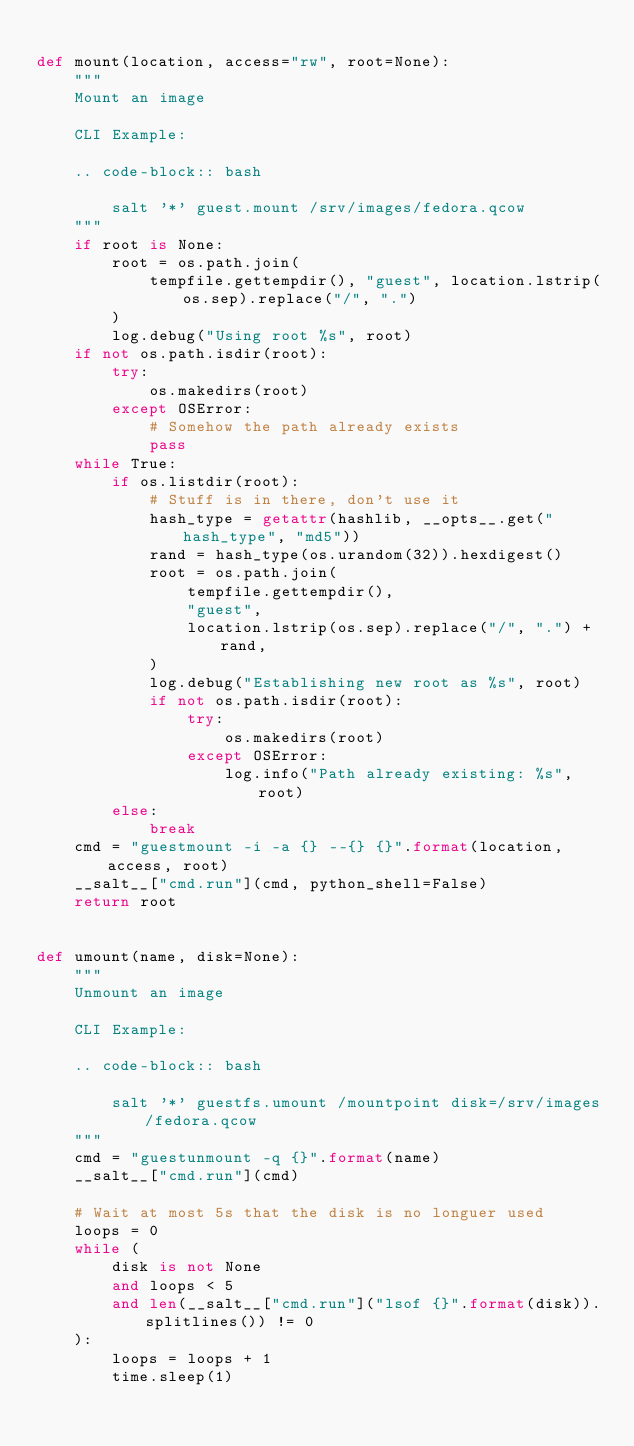<code> <loc_0><loc_0><loc_500><loc_500><_Python_>
def mount(location, access="rw", root=None):
    """
    Mount an image

    CLI Example:

    .. code-block:: bash

        salt '*' guest.mount /srv/images/fedora.qcow
    """
    if root is None:
        root = os.path.join(
            tempfile.gettempdir(), "guest", location.lstrip(os.sep).replace("/", ".")
        )
        log.debug("Using root %s", root)
    if not os.path.isdir(root):
        try:
            os.makedirs(root)
        except OSError:
            # Somehow the path already exists
            pass
    while True:
        if os.listdir(root):
            # Stuff is in there, don't use it
            hash_type = getattr(hashlib, __opts__.get("hash_type", "md5"))
            rand = hash_type(os.urandom(32)).hexdigest()
            root = os.path.join(
                tempfile.gettempdir(),
                "guest",
                location.lstrip(os.sep).replace("/", ".") + rand,
            )
            log.debug("Establishing new root as %s", root)
            if not os.path.isdir(root):
                try:
                    os.makedirs(root)
                except OSError:
                    log.info("Path already existing: %s", root)
        else:
            break
    cmd = "guestmount -i -a {} --{} {}".format(location, access, root)
    __salt__["cmd.run"](cmd, python_shell=False)
    return root


def umount(name, disk=None):
    """
    Unmount an image

    CLI Example:

    .. code-block:: bash

        salt '*' guestfs.umount /mountpoint disk=/srv/images/fedora.qcow
    """
    cmd = "guestunmount -q {}".format(name)
    __salt__["cmd.run"](cmd)

    # Wait at most 5s that the disk is no longuer used
    loops = 0
    while (
        disk is not None
        and loops < 5
        and len(__salt__["cmd.run"]("lsof {}".format(disk)).splitlines()) != 0
    ):
        loops = loops + 1
        time.sleep(1)
</code> 